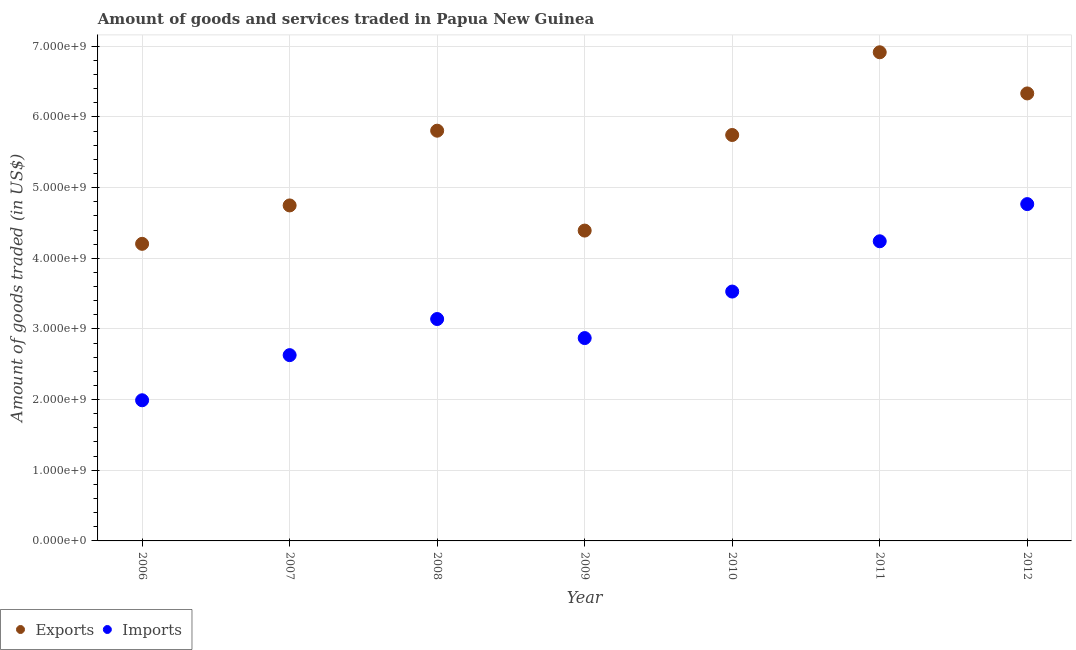What is the amount of goods exported in 2012?
Keep it short and to the point. 6.33e+09. Across all years, what is the maximum amount of goods imported?
Keep it short and to the point. 4.77e+09. Across all years, what is the minimum amount of goods exported?
Offer a very short reply. 4.20e+09. What is the total amount of goods exported in the graph?
Offer a terse response. 3.81e+1. What is the difference between the amount of goods imported in 2010 and that in 2011?
Give a very brief answer. -7.12e+08. What is the difference between the amount of goods exported in 2011 and the amount of goods imported in 2008?
Your answer should be very brief. 3.78e+09. What is the average amount of goods exported per year?
Ensure brevity in your answer.  5.45e+09. In the year 2009, what is the difference between the amount of goods exported and amount of goods imported?
Offer a terse response. 1.52e+09. What is the ratio of the amount of goods imported in 2010 to that in 2012?
Your answer should be very brief. 0.74. Is the amount of goods imported in 2007 less than that in 2011?
Keep it short and to the point. Yes. Is the difference between the amount of goods imported in 2006 and 2009 greater than the difference between the amount of goods exported in 2006 and 2009?
Keep it short and to the point. No. What is the difference between the highest and the second highest amount of goods imported?
Offer a terse response. 5.26e+08. What is the difference between the highest and the lowest amount of goods exported?
Keep it short and to the point. 2.71e+09. In how many years, is the amount of goods imported greater than the average amount of goods imported taken over all years?
Your response must be concise. 3. Is the sum of the amount of goods imported in 2008 and 2011 greater than the maximum amount of goods exported across all years?
Your response must be concise. Yes. Does the amount of goods exported monotonically increase over the years?
Your response must be concise. No. Is the amount of goods imported strictly greater than the amount of goods exported over the years?
Your answer should be very brief. No. How many years are there in the graph?
Give a very brief answer. 7. What is the difference between two consecutive major ticks on the Y-axis?
Keep it short and to the point. 1.00e+09. Does the graph contain grids?
Ensure brevity in your answer.  Yes. How are the legend labels stacked?
Offer a very short reply. Horizontal. What is the title of the graph?
Offer a very short reply. Amount of goods and services traded in Papua New Guinea. What is the label or title of the X-axis?
Make the answer very short. Year. What is the label or title of the Y-axis?
Your answer should be compact. Amount of goods traded (in US$). What is the Amount of goods traded (in US$) in Exports in 2006?
Provide a succinct answer. 4.20e+09. What is the Amount of goods traded (in US$) of Imports in 2006?
Provide a short and direct response. 1.99e+09. What is the Amount of goods traded (in US$) in Exports in 2007?
Your response must be concise. 4.75e+09. What is the Amount of goods traded (in US$) of Imports in 2007?
Offer a very short reply. 2.63e+09. What is the Amount of goods traded (in US$) of Exports in 2008?
Keep it short and to the point. 5.81e+09. What is the Amount of goods traded (in US$) in Imports in 2008?
Your answer should be compact. 3.14e+09. What is the Amount of goods traded (in US$) of Exports in 2009?
Give a very brief answer. 4.39e+09. What is the Amount of goods traded (in US$) of Imports in 2009?
Make the answer very short. 2.87e+09. What is the Amount of goods traded (in US$) in Exports in 2010?
Your answer should be compact. 5.74e+09. What is the Amount of goods traded (in US$) of Imports in 2010?
Offer a very short reply. 3.53e+09. What is the Amount of goods traded (in US$) of Exports in 2011?
Offer a terse response. 6.92e+09. What is the Amount of goods traded (in US$) of Imports in 2011?
Give a very brief answer. 4.24e+09. What is the Amount of goods traded (in US$) in Exports in 2012?
Your answer should be very brief. 6.33e+09. What is the Amount of goods traded (in US$) of Imports in 2012?
Give a very brief answer. 4.77e+09. Across all years, what is the maximum Amount of goods traded (in US$) of Exports?
Make the answer very short. 6.92e+09. Across all years, what is the maximum Amount of goods traded (in US$) in Imports?
Your answer should be very brief. 4.77e+09. Across all years, what is the minimum Amount of goods traded (in US$) of Exports?
Provide a short and direct response. 4.20e+09. Across all years, what is the minimum Amount of goods traded (in US$) of Imports?
Your response must be concise. 1.99e+09. What is the total Amount of goods traded (in US$) in Exports in the graph?
Offer a very short reply. 3.81e+1. What is the total Amount of goods traded (in US$) in Imports in the graph?
Your answer should be very brief. 2.32e+1. What is the difference between the Amount of goods traded (in US$) in Exports in 2006 and that in 2007?
Your response must be concise. -5.43e+08. What is the difference between the Amount of goods traded (in US$) in Imports in 2006 and that in 2007?
Your response must be concise. -6.39e+08. What is the difference between the Amount of goods traded (in US$) in Exports in 2006 and that in 2008?
Your answer should be very brief. -1.60e+09. What is the difference between the Amount of goods traded (in US$) of Imports in 2006 and that in 2008?
Provide a short and direct response. -1.15e+09. What is the difference between the Amount of goods traded (in US$) in Exports in 2006 and that in 2009?
Your answer should be very brief. -1.88e+08. What is the difference between the Amount of goods traded (in US$) in Imports in 2006 and that in 2009?
Make the answer very short. -8.80e+08. What is the difference between the Amount of goods traded (in US$) of Exports in 2006 and that in 2010?
Give a very brief answer. -1.54e+09. What is the difference between the Amount of goods traded (in US$) in Imports in 2006 and that in 2010?
Keep it short and to the point. -1.54e+09. What is the difference between the Amount of goods traded (in US$) of Exports in 2006 and that in 2011?
Provide a short and direct response. -2.71e+09. What is the difference between the Amount of goods traded (in US$) of Imports in 2006 and that in 2011?
Your response must be concise. -2.25e+09. What is the difference between the Amount of goods traded (in US$) in Exports in 2006 and that in 2012?
Ensure brevity in your answer.  -2.13e+09. What is the difference between the Amount of goods traded (in US$) of Imports in 2006 and that in 2012?
Your response must be concise. -2.78e+09. What is the difference between the Amount of goods traded (in US$) of Exports in 2007 and that in 2008?
Your response must be concise. -1.06e+09. What is the difference between the Amount of goods traded (in US$) in Imports in 2007 and that in 2008?
Your answer should be very brief. -5.11e+08. What is the difference between the Amount of goods traded (in US$) of Exports in 2007 and that in 2009?
Offer a very short reply. 3.56e+08. What is the difference between the Amount of goods traded (in US$) in Imports in 2007 and that in 2009?
Ensure brevity in your answer.  -2.41e+08. What is the difference between the Amount of goods traded (in US$) in Exports in 2007 and that in 2010?
Offer a very short reply. -9.97e+08. What is the difference between the Amount of goods traded (in US$) of Imports in 2007 and that in 2010?
Offer a very short reply. -9.00e+08. What is the difference between the Amount of goods traded (in US$) of Exports in 2007 and that in 2011?
Provide a short and direct response. -2.17e+09. What is the difference between the Amount of goods traded (in US$) of Imports in 2007 and that in 2011?
Make the answer very short. -1.61e+09. What is the difference between the Amount of goods traded (in US$) in Exports in 2007 and that in 2012?
Provide a short and direct response. -1.58e+09. What is the difference between the Amount of goods traded (in US$) of Imports in 2007 and that in 2012?
Offer a terse response. -2.14e+09. What is the difference between the Amount of goods traded (in US$) of Exports in 2008 and that in 2009?
Provide a succinct answer. 1.41e+09. What is the difference between the Amount of goods traded (in US$) in Imports in 2008 and that in 2009?
Make the answer very short. 2.69e+08. What is the difference between the Amount of goods traded (in US$) in Exports in 2008 and that in 2010?
Your answer should be compact. 6.08e+07. What is the difference between the Amount of goods traded (in US$) in Imports in 2008 and that in 2010?
Ensure brevity in your answer.  -3.89e+08. What is the difference between the Amount of goods traded (in US$) in Exports in 2008 and that in 2011?
Offer a very short reply. -1.11e+09. What is the difference between the Amount of goods traded (in US$) in Imports in 2008 and that in 2011?
Give a very brief answer. -1.10e+09. What is the difference between the Amount of goods traded (in US$) in Exports in 2008 and that in 2012?
Give a very brief answer. -5.27e+08. What is the difference between the Amount of goods traded (in US$) in Imports in 2008 and that in 2012?
Provide a succinct answer. -1.63e+09. What is the difference between the Amount of goods traded (in US$) of Exports in 2009 and that in 2010?
Your answer should be compact. -1.35e+09. What is the difference between the Amount of goods traded (in US$) in Imports in 2009 and that in 2010?
Your response must be concise. -6.58e+08. What is the difference between the Amount of goods traded (in US$) in Exports in 2009 and that in 2011?
Provide a short and direct response. -2.52e+09. What is the difference between the Amount of goods traded (in US$) in Imports in 2009 and that in 2011?
Offer a terse response. -1.37e+09. What is the difference between the Amount of goods traded (in US$) in Exports in 2009 and that in 2012?
Keep it short and to the point. -1.94e+09. What is the difference between the Amount of goods traded (in US$) of Imports in 2009 and that in 2012?
Make the answer very short. -1.90e+09. What is the difference between the Amount of goods traded (in US$) in Exports in 2010 and that in 2011?
Offer a very short reply. -1.17e+09. What is the difference between the Amount of goods traded (in US$) in Imports in 2010 and that in 2011?
Make the answer very short. -7.12e+08. What is the difference between the Amount of goods traded (in US$) of Exports in 2010 and that in 2012?
Ensure brevity in your answer.  -5.88e+08. What is the difference between the Amount of goods traded (in US$) of Imports in 2010 and that in 2012?
Ensure brevity in your answer.  -1.24e+09. What is the difference between the Amount of goods traded (in US$) in Exports in 2011 and that in 2012?
Give a very brief answer. 5.82e+08. What is the difference between the Amount of goods traded (in US$) in Imports in 2011 and that in 2012?
Provide a succinct answer. -5.26e+08. What is the difference between the Amount of goods traded (in US$) in Exports in 2006 and the Amount of goods traded (in US$) in Imports in 2007?
Give a very brief answer. 1.58e+09. What is the difference between the Amount of goods traded (in US$) of Exports in 2006 and the Amount of goods traded (in US$) of Imports in 2008?
Your answer should be compact. 1.06e+09. What is the difference between the Amount of goods traded (in US$) in Exports in 2006 and the Amount of goods traded (in US$) in Imports in 2009?
Give a very brief answer. 1.33e+09. What is the difference between the Amount of goods traded (in US$) in Exports in 2006 and the Amount of goods traded (in US$) in Imports in 2010?
Ensure brevity in your answer.  6.75e+08. What is the difference between the Amount of goods traded (in US$) of Exports in 2006 and the Amount of goods traded (in US$) of Imports in 2011?
Provide a succinct answer. -3.62e+07. What is the difference between the Amount of goods traded (in US$) of Exports in 2006 and the Amount of goods traded (in US$) of Imports in 2012?
Your answer should be compact. -5.62e+08. What is the difference between the Amount of goods traded (in US$) in Exports in 2007 and the Amount of goods traded (in US$) in Imports in 2008?
Offer a very short reply. 1.61e+09. What is the difference between the Amount of goods traded (in US$) in Exports in 2007 and the Amount of goods traded (in US$) in Imports in 2009?
Make the answer very short. 1.88e+09. What is the difference between the Amount of goods traded (in US$) of Exports in 2007 and the Amount of goods traded (in US$) of Imports in 2010?
Offer a terse response. 1.22e+09. What is the difference between the Amount of goods traded (in US$) in Exports in 2007 and the Amount of goods traded (in US$) in Imports in 2011?
Keep it short and to the point. 5.07e+08. What is the difference between the Amount of goods traded (in US$) of Exports in 2007 and the Amount of goods traded (in US$) of Imports in 2012?
Make the answer very short. -1.88e+07. What is the difference between the Amount of goods traded (in US$) in Exports in 2008 and the Amount of goods traded (in US$) in Imports in 2009?
Provide a short and direct response. 2.93e+09. What is the difference between the Amount of goods traded (in US$) of Exports in 2008 and the Amount of goods traded (in US$) of Imports in 2010?
Provide a short and direct response. 2.28e+09. What is the difference between the Amount of goods traded (in US$) in Exports in 2008 and the Amount of goods traded (in US$) in Imports in 2011?
Provide a succinct answer. 1.57e+09. What is the difference between the Amount of goods traded (in US$) in Exports in 2008 and the Amount of goods traded (in US$) in Imports in 2012?
Provide a short and direct response. 1.04e+09. What is the difference between the Amount of goods traded (in US$) of Exports in 2009 and the Amount of goods traded (in US$) of Imports in 2010?
Provide a succinct answer. 8.63e+08. What is the difference between the Amount of goods traded (in US$) of Exports in 2009 and the Amount of goods traded (in US$) of Imports in 2011?
Make the answer very short. 1.51e+08. What is the difference between the Amount of goods traded (in US$) of Exports in 2009 and the Amount of goods traded (in US$) of Imports in 2012?
Your answer should be very brief. -3.75e+08. What is the difference between the Amount of goods traded (in US$) in Exports in 2010 and the Amount of goods traded (in US$) in Imports in 2011?
Your response must be concise. 1.50e+09. What is the difference between the Amount of goods traded (in US$) in Exports in 2010 and the Amount of goods traded (in US$) in Imports in 2012?
Offer a terse response. 9.78e+08. What is the difference between the Amount of goods traded (in US$) in Exports in 2011 and the Amount of goods traded (in US$) in Imports in 2012?
Offer a very short reply. 2.15e+09. What is the average Amount of goods traded (in US$) of Exports per year?
Provide a short and direct response. 5.45e+09. What is the average Amount of goods traded (in US$) in Imports per year?
Ensure brevity in your answer.  3.31e+09. In the year 2006, what is the difference between the Amount of goods traded (in US$) in Exports and Amount of goods traded (in US$) in Imports?
Offer a terse response. 2.21e+09. In the year 2007, what is the difference between the Amount of goods traded (in US$) of Exports and Amount of goods traded (in US$) of Imports?
Provide a succinct answer. 2.12e+09. In the year 2008, what is the difference between the Amount of goods traded (in US$) of Exports and Amount of goods traded (in US$) of Imports?
Make the answer very short. 2.67e+09. In the year 2009, what is the difference between the Amount of goods traded (in US$) of Exports and Amount of goods traded (in US$) of Imports?
Offer a very short reply. 1.52e+09. In the year 2010, what is the difference between the Amount of goods traded (in US$) of Exports and Amount of goods traded (in US$) of Imports?
Your answer should be compact. 2.22e+09. In the year 2011, what is the difference between the Amount of goods traded (in US$) in Exports and Amount of goods traded (in US$) in Imports?
Ensure brevity in your answer.  2.67e+09. In the year 2012, what is the difference between the Amount of goods traded (in US$) in Exports and Amount of goods traded (in US$) in Imports?
Keep it short and to the point. 1.57e+09. What is the ratio of the Amount of goods traded (in US$) in Exports in 2006 to that in 2007?
Keep it short and to the point. 0.89. What is the ratio of the Amount of goods traded (in US$) of Imports in 2006 to that in 2007?
Offer a very short reply. 0.76. What is the ratio of the Amount of goods traded (in US$) of Exports in 2006 to that in 2008?
Provide a succinct answer. 0.72. What is the ratio of the Amount of goods traded (in US$) in Imports in 2006 to that in 2008?
Provide a succinct answer. 0.63. What is the ratio of the Amount of goods traded (in US$) of Exports in 2006 to that in 2009?
Ensure brevity in your answer.  0.96. What is the ratio of the Amount of goods traded (in US$) in Imports in 2006 to that in 2009?
Keep it short and to the point. 0.69. What is the ratio of the Amount of goods traded (in US$) of Exports in 2006 to that in 2010?
Offer a terse response. 0.73. What is the ratio of the Amount of goods traded (in US$) in Imports in 2006 to that in 2010?
Keep it short and to the point. 0.56. What is the ratio of the Amount of goods traded (in US$) of Exports in 2006 to that in 2011?
Your answer should be very brief. 0.61. What is the ratio of the Amount of goods traded (in US$) in Imports in 2006 to that in 2011?
Provide a short and direct response. 0.47. What is the ratio of the Amount of goods traded (in US$) in Exports in 2006 to that in 2012?
Offer a terse response. 0.66. What is the ratio of the Amount of goods traded (in US$) in Imports in 2006 to that in 2012?
Give a very brief answer. 0.42. What is the ratio of the Amount of goods traded (in US$) of Exports in 2007 to that in 2008?
Your answer should be very brief. 0.82. What is the ratio of the Amount of goods traded (in US$) of Imports in 2007 to that in 2008?
Make the answer very short. 0.84. What is the ratio of the Amount of goods traded (in US$) in Exports in 2007 to that in 2009?
Your answer should be very brief. 1.08. What is the ratio of the Amount of goods traded (in US$) in Imports in 2007 to that in 2009?
Your answer should be very brief. 0.92. What is the ratio of the Amount of goods traded (in US$) in Exports in 2007 to that in 2010?
Make the answer very short. 0.83. What is the ratio of the Amount of goods traded (in US$) in Imports in 2007 to that in 2010?
Provide a short and direct response. 0.75. What is the ratio of the Amount of goods traded (in US$) of Exports in 2007 to that in 2011?
Ensure brevity in your answer.  0.69. What is the ratio of the Amount of goods traded (in US$) of Imports in 2007 to that in 2011?
Offer a very short reply. 0.62. What is the ratio of the Amount of goods traded (in US$) in Exports in 2007 to that in 2012?
Your response must be concise. 0.75. What is the ratio of the Amount of goods traded (in US$) in Imports in 2007 to that in 2012?
Give a very brief answer. 0.55. What is the ratio of the Amount of goods traded (in US$) in Exports in 2008 to that in 2009?
Provide a short and direct response. 1.32. What is the ratio of the Amount of goods traded (in US$) of Imports in 2008 to that in 2009?
Your answer should be very brief. 1.09. What is the ratio of the Amount of goods traded (in US$) of Exports in 2008 to that in 2010?
Provide a succinct answer. 1.01. What is the ratio of the Amount of goods traded (in US$) in Imports in 2008 to that in 2010?
Keep it short and to the point. 0.89. What is the ratio of the Amount of goods traded (in US$) of Exports in 2008 to that in 2011?
Your answer should be very brief. 0.84. What is the ratio of the Amount of goods traded (in US$) in Imports in 2008 to that in 2011?
Provide a short and direct response. 0.74. What is the ratio of the Amount of goods traded (in US$) in Exports in 2008 to that in 2012?
Your answer should be very brief. 0.92. What is the ratio of the Amount of goods traded (in US$) of Imports in 2008 to that in 2012?
Ensure brevity in your answer.  0.66. What is the ratio of the Amount of goods traded (in US$) in Exports in 2009 to that in 2010?
Your answer should be very brief. 0.76. What is the ratio of the Amount of goods traded (in US$) in Imports in 2009 to that in 2010?
Make the answer very short. 0.81. What is the ratio of the Amount of goods traded (in US$) in Exports in 2009 to that in 2011?
Give a very brief answer. 0.64. What is the ratio of the Amount of goods traded (in US$) of Imports in 2009 to that in 2011?
Give a very brief answer. 0.68. What is the ratio of the Amount of goods traded (in US$) in Exports in 2009 to that in 2012?
Your response must be concise. 0.69. What is the ratio of the Amount of goods traded (in US$) of Imports in 2009 to that in 2012?
Provide a short and direct response. 0.6. What is the ratio of the Amount of goods traded (in US$) of Exports in 2010 to that in 2011?
Provide a short and direct response. 0.83. What is the ratio of the Amount of goods traded (in US$) in Imports in 2010 to that in 2011?
Offer a very short reply. 0.83. What is the ratio of the Amount of goods traded (in US$) of Exports in 2010 to that in 2012?
Offer a very short reply. 0.91. What is the ratio of the Amount of goods traded (in US$) in Imports in 2010 to that in 2012?
Provide a succinct answer. 0.74. What is the ratio of the Amount of goods traded (in US$) of Exports in 2011 to that in 2012?
Offer a very short reply. 1.09. What is the ratio of the Amount of goods traded (in US$) in Imports in 2011 to that in 2012?
Provide a short and direct response. 0.89. What is the difference between the highest and the second highest Amount of goods traded (in US$) of Exports?
Provide a short and direct response. 5.82e+08. What is the difference between the highest and the second highest Amount of goods traded (in US$) of Imports?
Your answer should be very brief. 5.26e+08. What is the difference between the highest and the lowest Amount of goods traded (in US$) of Exports?
Offer a very short reply. 2.71e+09. What is the difference between the highest and the lowest Amount of goods traded (in US$) of Imports?
Provide a succinct answer. 2.78e+09. 